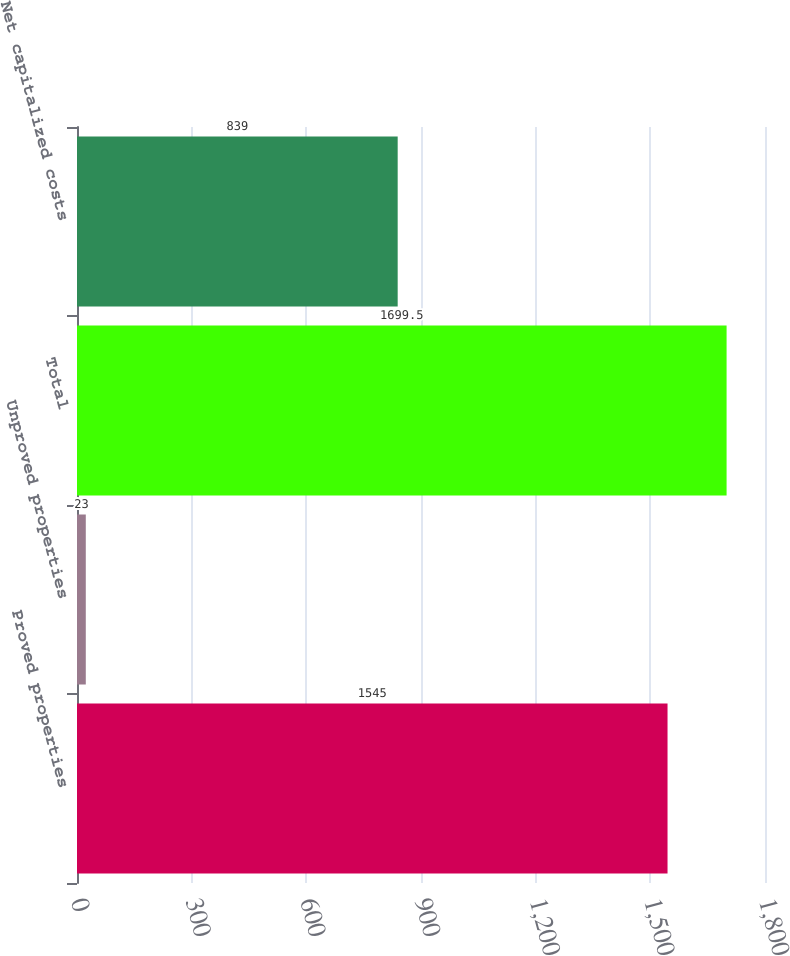Convert chart. <chart><loc_0><loc_0><loc_500><loc_500><bar_chart><fcel>Proved properties<fcel>Unproved properties<fcel>Total<fcel>Net capitalized costs<nl><fcel>1545<fcel>23<fcel>1699.5<fcel>839<nl></chart> 